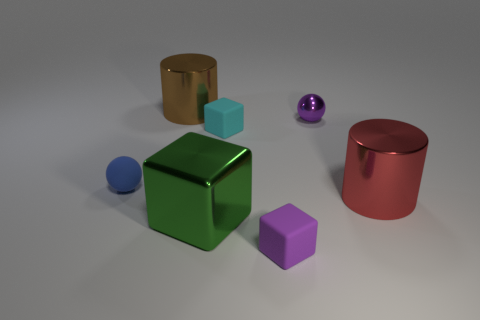There is a object that is the same color as the small metallic ball; what size is it?
Your answer should be compact. Small. How many things are either large blue objects or purple objects?
Your answer should be very brief. 2. Is there a tiny red thing?
Offer a very short reply. No. Do the small purple thing behind the red metallic cylinder and the green object have the same material?
Ensure brevity in your answer.  Yes. Is there another thing that has the same shape as the tiny blue rubber thing?
Make the answer very short. Yes. Is the number of tiny blue matte spheres that are in front of the blue sphere the same as the number of green objects?
Provide a short and direct response. No. What is the cylinder that is in front of the cylinder that is left of the large metal cube made of?
Keep it short and to the point. Metal. What shape is the large green metal object?
Provide a succinct answer. Cube. Are there the same number of shiny objects on the right side of the cyan block and big brown objects that are on the right side of the big green metal cube?
Give a very brief answer. No. There is a metallic cylinder that is right of the brown cylinder; is it the same color as the shiny cylinder that is on the left side of the purple metallic object?
Your answer should be compact. No. 